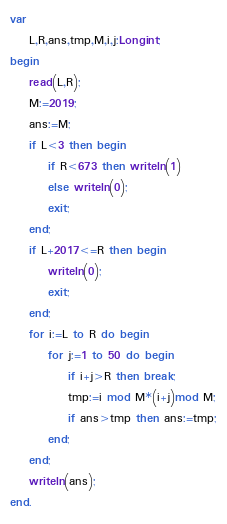Convert code to text. <code><loc_0><loc_0><loc_500><loc_500><_Pascal_>var
	L,R,ans,tmp,M,i,j:Longint;
begin
	read(L,R);
	M:=2019;
	ans:=M;
	if L<3 then begin
		if R<673 then writeln(1)
		else writeln(0);
		exit;
	end;
	if L+2017<=R then begin
		writeln(0);
		exit;
	end;
	for i:=L to R do begin
		for j:=1 to 50 do begin
			if i+j>R then break;
			tmp:=i mod M*(i+j)mod M;
			if ans>tmp then ans:=tmp;
		end;
	end;
	writeln(ans);
end.</code> 